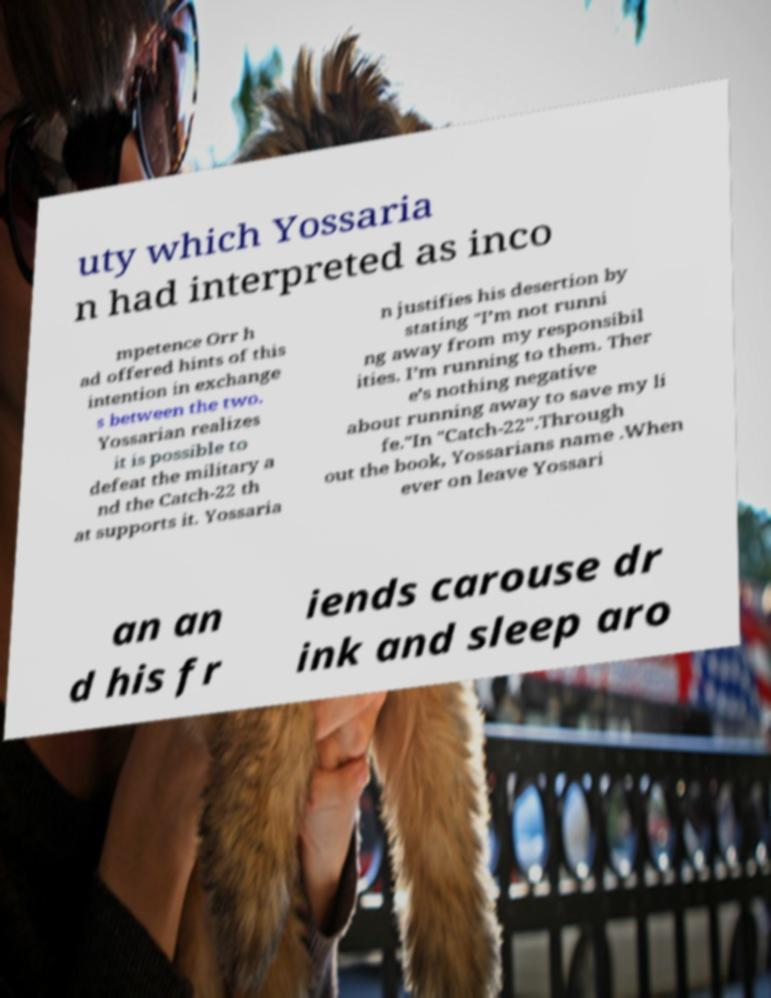There's text embedded in this image that I need extracted. Can you transcribe it verbatim? uty which Yossaria n had interpreted as inco mpetence Orr h ad offered hints of this intention in exchange s between the two. Yossarian realizes it is possible to defeat the military a nd the Catch-22 th at supports it. Yossaria n justifies his desertion by stating "I’m not runni ng away from my responsibil ities. I’m running to them. Ther e’s nothing negative about running away to save my li fe."In "Catch-22".Through out the book, Yossarians name .When ever on leave Yossari an an d his fr iends carouse dr ink and sleep aro 